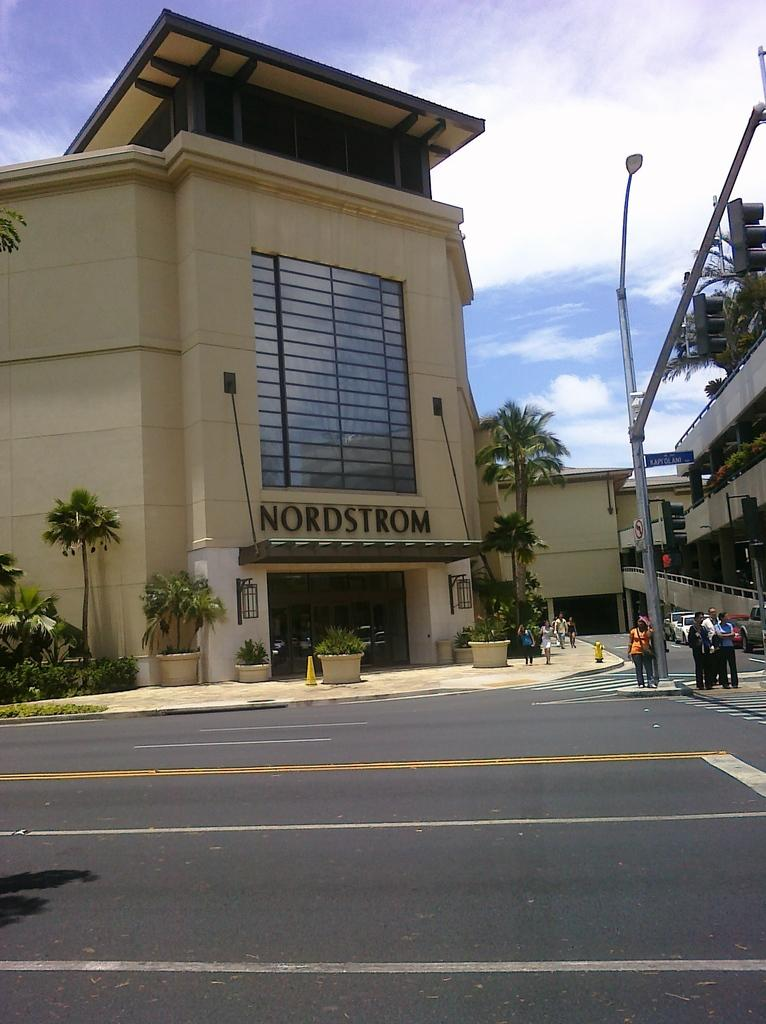<image>
Offer a succinct explanation of the picture presented. The outside of the retailer Nordstrom in a warm place with palm trees. 